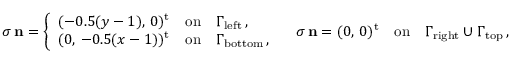<formula> <loc_0><loc_0><loc_500><loc_500>{ \boldsymbol \sigma } \, { n } = \left \{ \begin{array} { c l l } { ( - 0 . 5 ( y - 1 ) , \, 0 ) ^ { t } } & { o n } & { \Gamma _ { l e f t } \, , } \\ { ( 0 , \, - 0 . 5 ( x - 1 ) ) ^ { t } } & { o n } & { \Gamma _ { b o t t o m } \, , } \end{array} \quad \boldsymbol \sigma \, { n } = ( 0 , \, 0 ) ^ { t } { \quad o n \quad } \Gamma _ { r i g h t } \cup \Gamma _ { t o p } \, ,</formula> 